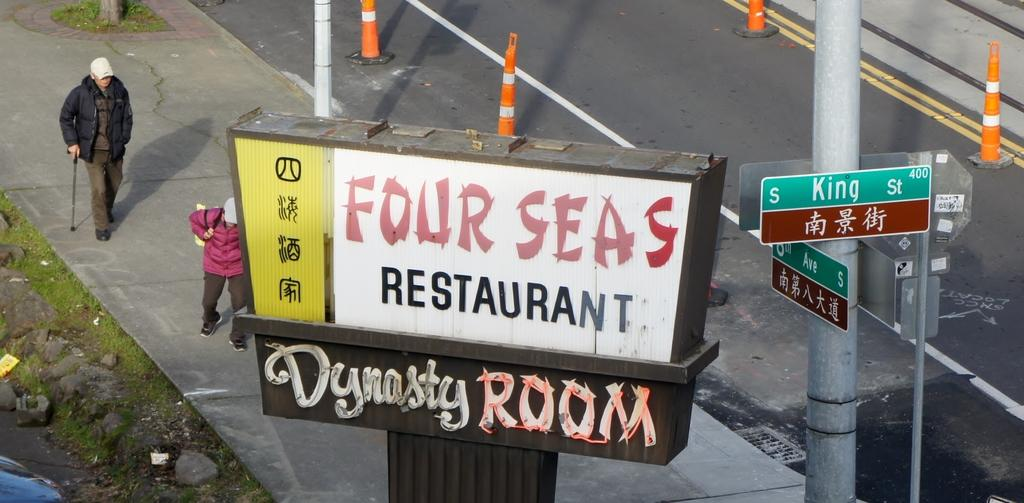<image>
Give a short and clear explanation of the subsequent image. Sign for a restaurant which says "FOur Seas Restaurant". 